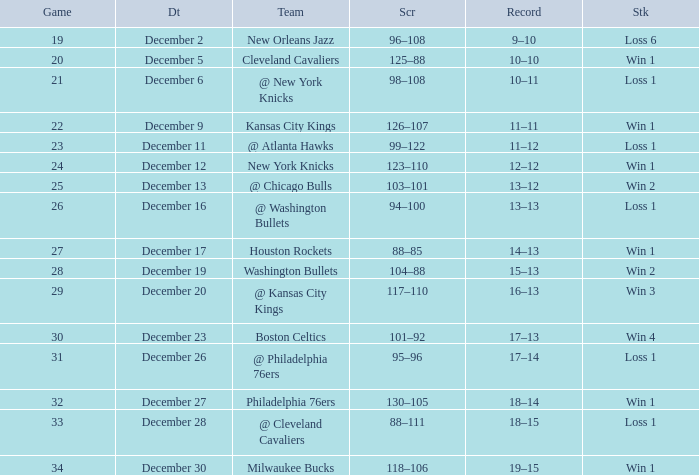What is the Streak on December 30? Win 1. 